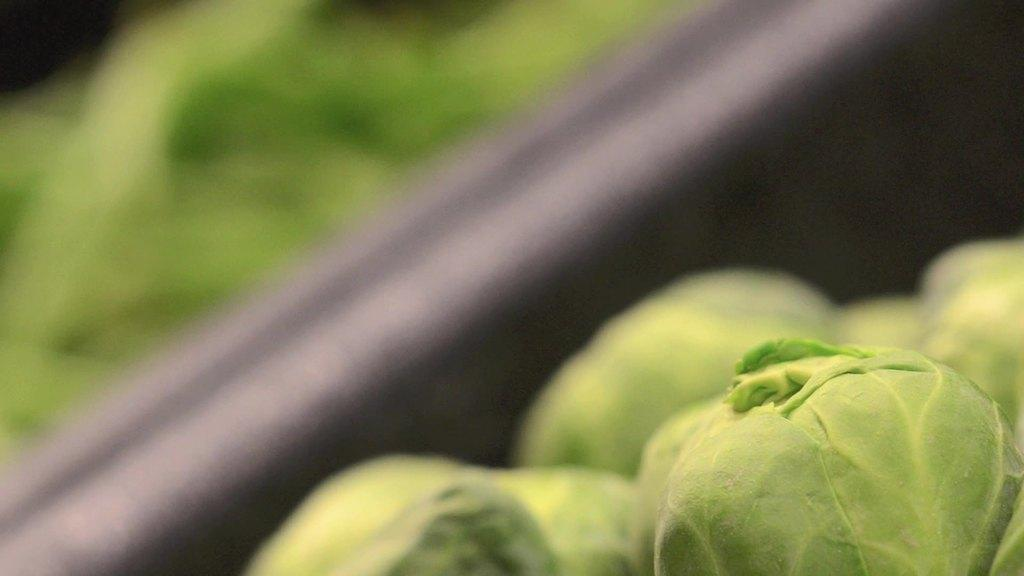What type of vegetable is in the middle of the image? There are cabbages in the middle of the image. What can be seen besides the cabbages in the image? There is a black color pipe in the image. What type of bomb is hidden among the cabbages in the image? There is no bomb present in the image; it only features cabbages and a black color pipe. 